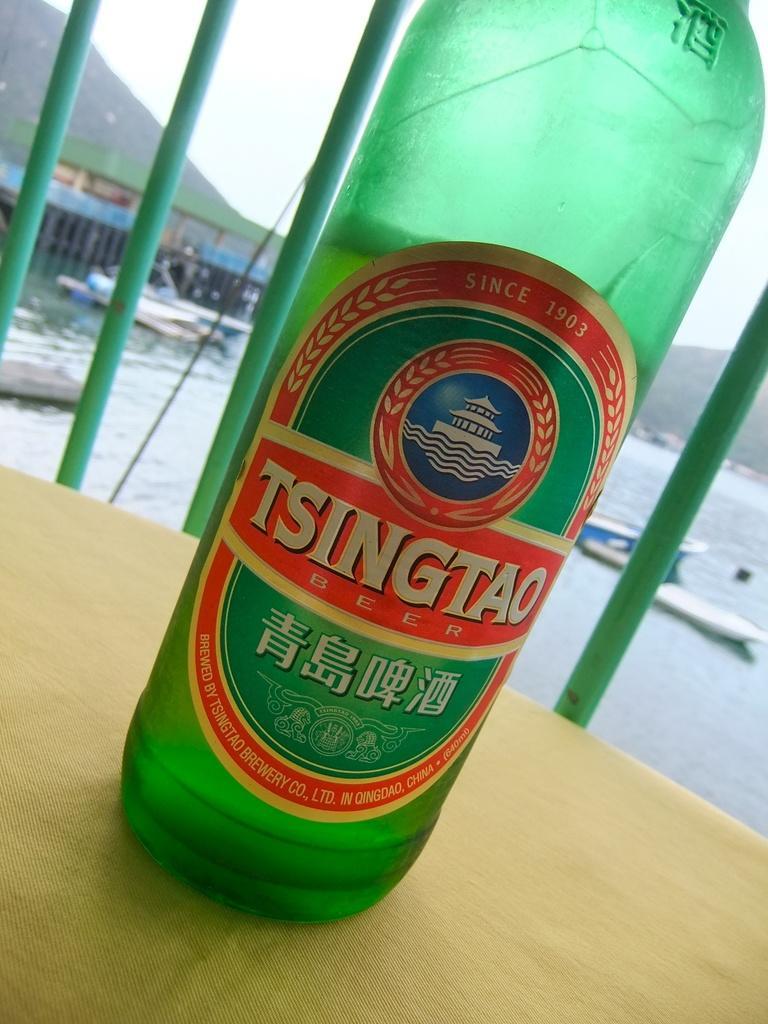Please provide a concise description of this image. There is a bottle. This is water and there are boats. On the background there is a sky and this is mountain. 